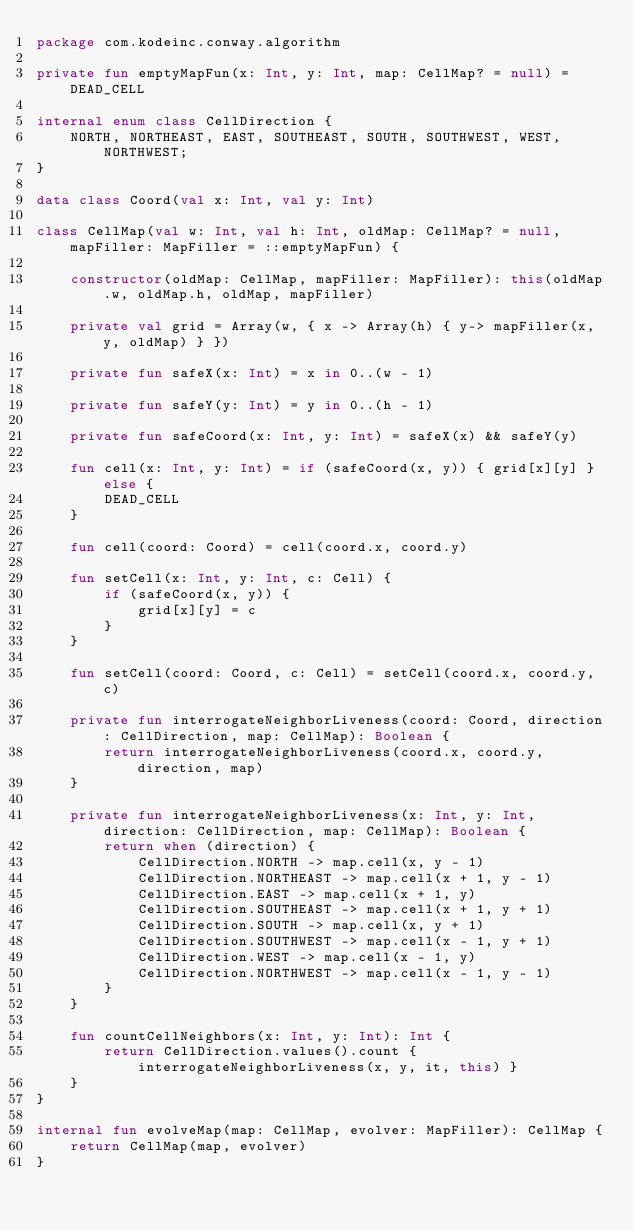<code> <loc_0><loc_0><loc_500><loc_500><_Kotlin_>package com.kodeinc.conway.algorithm

private fun emptyMapFun(x: Int, y: Int, map: CellMap? = null) = DEAD_CELL

internal enum class CellDirection {
    NORTH, NORTHEAST, EAST, SOUTHEAST, SOUTH, SOUTHWEST, WEST, NORTHWEST;
}

data class Coord(val x: Int, val y: Int)

class CellMap(val w: Int, val h: Int, oldMap: CellMap? = null, mapFiller: MapFiller = ::emptyMapFun) {

    constructor(oldMap: CellMap, mapFiller: MapFiller): this(oldMap.w, oldMap.h, oldMap, mapFiller)

    private val grid = Array(w, { x -> Array(h) { y-> mapFiller(x, y, oldMap) } })

    private fun safeX(x: Int) = x in 0..(w - 1)

    private fun safeY(y: Int) = y in 0..(h - 1)

    private fun safeCoord(x: Int, y: Int) = safeX(x) && safeY(y)

    fun cell(x: Int, y: Int) = if (safeCoord(x, y)) { grid[x][y] } else {
        DEAD_CELL
    }

    fun cell(coord: Coord) = cell(coord.x, coord.y)

    fun setCell(x: Int, y: Int, c: Cell) {
        if (safeCoord(x, y)) {
            grid[x][y] = c
        }
    }

    fun setCell(coord: Coord, c: Cell) = setCell(coord.x, coord.y, c)

    private fun interrogateNeighborLiveness(coord: Coord, direction: CellDirection, map: CellMap): Boolean {
        return interrogateNeighborLiveness(coord.x, coord.y, direction, map)
    }

    private fun interrogateNeighborLiveness(x: Int, y: Int, direction: CellDirection, map: CellMap): Boolean {
        return when (direction) {
            CellDirection.NORTH -> map.cell(x, y - 1)
            CellDirection.NORTHEAST -> map.cell(x + 1, y - 1)
            CellDirection.EAST -> map.cell(x + 1, y)
            CellDirection.SOUTHEAST -> map.cell(x + 1, y + 1)
            CellDirection.SOUTH -> map.cell(x, y + 1)
            CellDirection.SOUTHWEST -> map.cell(x - 1, y + 1)
            CellDirection.WEST -> map.cell(x - 1, y)
            CellDirection.NORTHWEST -> map.cell(x - 1, y - 1)
        }
    }

    fun countCellNeighbors(x: Int, y: Int): Int {
        return CellDirection.values().count { interrogateNeighborLiveness(x, y, it, this) }
    }
}

internal fun evolveMap(map: CellMap, evolver: MapFiller): CellMap {
    return CellMap(map, evolver)
}
</code> 